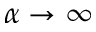Convert formula to latex. <formula><loc_0><loc_0><loc_500><loc_500>\alpha \to \infty</formula> 